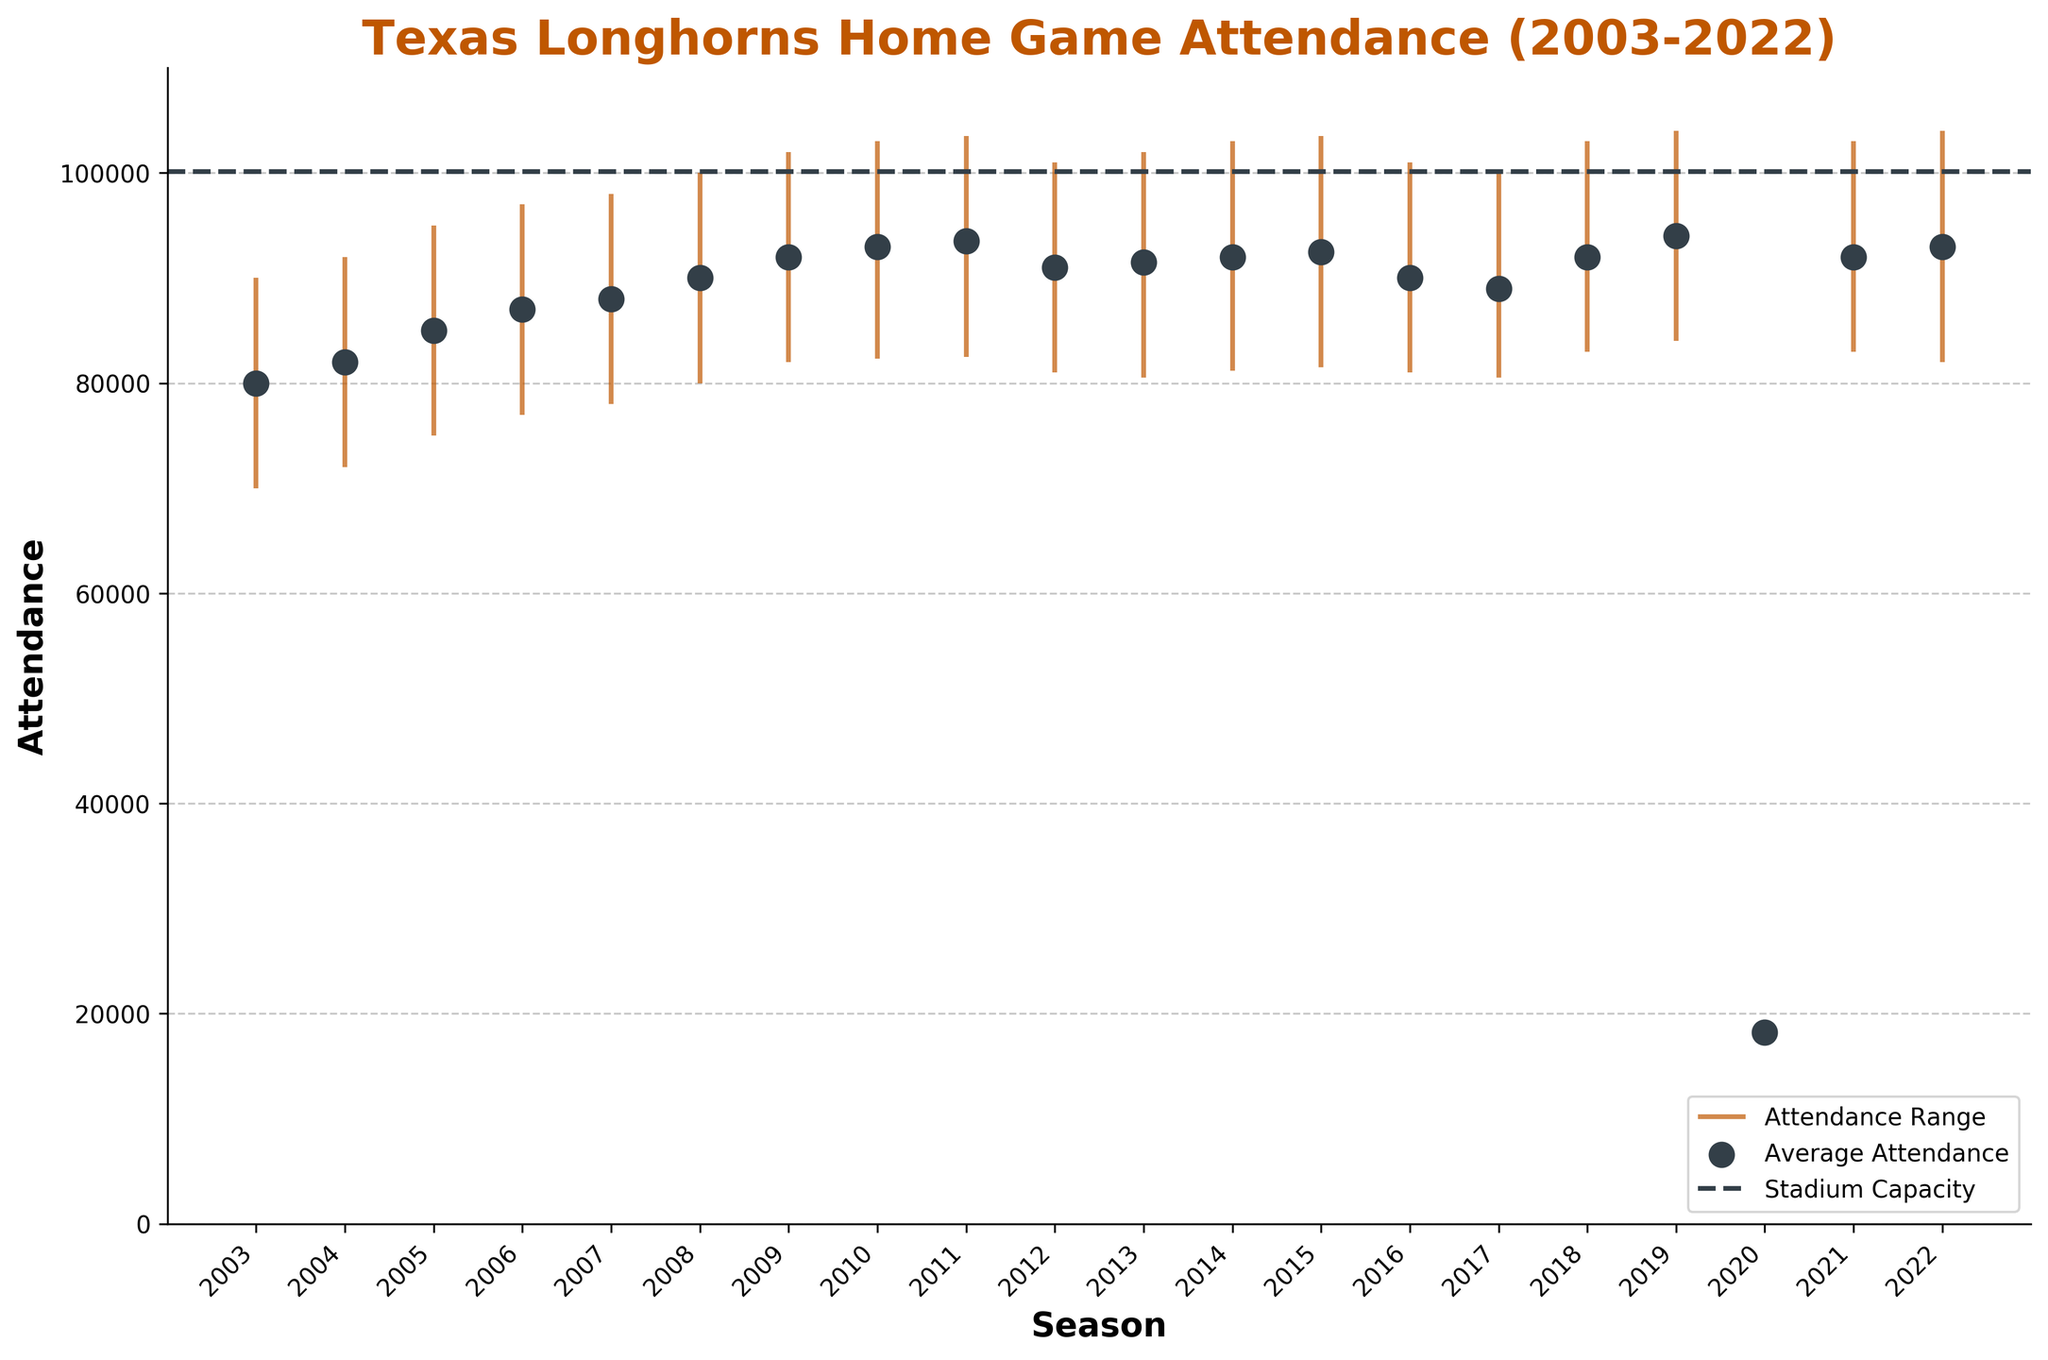what is the title of the figure? The title of the figure is located at the top and typically gives a summary description of the data visualized. In this case, it is the heading text in bold and matches the dataset we're discussing.
Answer: Texas Longhorns Home Game Attendance (2003-2022) How many seasons are depicted in the figure? Count the number of unique x-axis labels representing each season.
Answer: 20 What's the maximum attendance for the year 2009? Refer to the data point for 2009; look for the highest point reached by the vertical line.
Answer: 102,000 During which season did the Longhorns have their lowest average attendance? Locate and compare the position of the dot representing average attendance value that is closest to the lowest on the y-axis.
Answer: 2020 How does the average attendance in 2020 compare to the average attendance in 2021? Identify the average attendance dots for both 2020 and 2021 and compare their positions on the vertical axis.
Answer: 2020 is significantly lower than 2021 Which season had an average attendance closest to the stadium capacity of 100,119? Compare average attendance points to the stadium capacity line at 100,119 and identify the closest one.
Answer: 2019 What's the range of attendance for the season 2015? Find the endpoints of the vertical line representing 2015; subtract the lowest value from the highest value. For 2015, the max is 103,500 and the min is 81,500, subtract min from max.
Answer: 22,000 Which year had the highest minimum attendance, and what was it? Identify the season with the highest point for minimum attendance by comparing the bottom ends of the vertical lines.
Answer: 2019, 84,000 What is the trend in average attendance from 2003 to 2022? Observe the dots representing average attendance over the years to identify patterns such as increases or decreases.
Answer: Generally increasing until 2019, then a drop in 2020, followed by a recovery Compare the overall attendance range in 2020 to the one in 2008. Measure the length of the vertical lines for both years and compare their differences.
Answer: 2020's range is much smaller than 2008's 